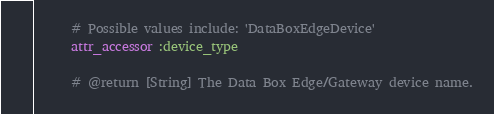Convert code to text. <code><loc_0><loc_0><loc_500><loc_500><_Ruby_>      # Possible values include: 'DataBoxEdgeDevice'
      attr_accessor :device_type

      # @return [String] The Data Box Edge/Gateway device name.</code> 